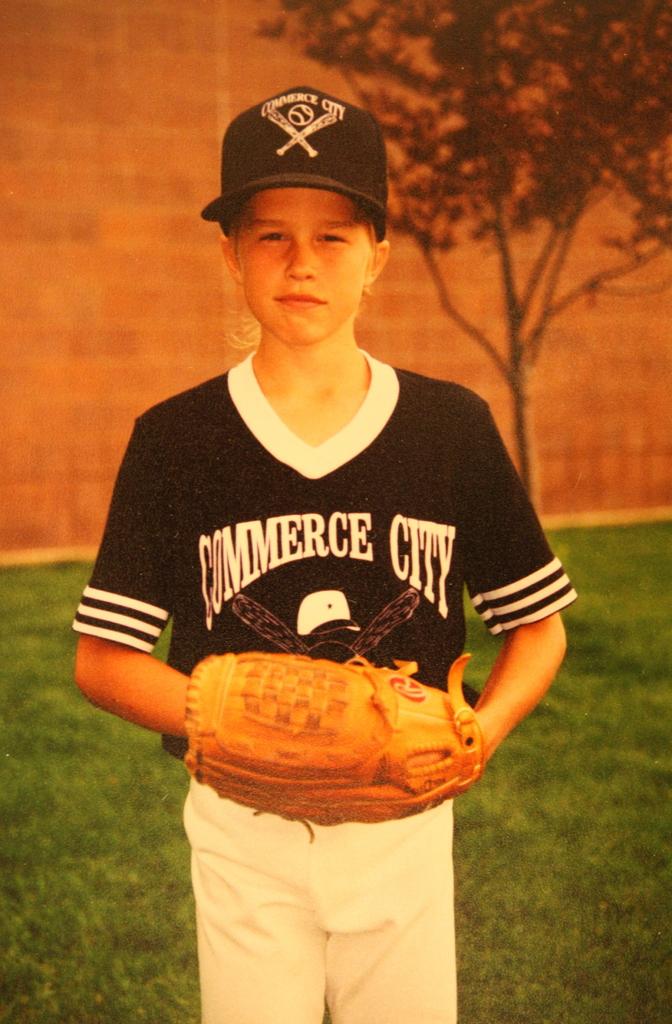What city does the boy play for?
Your response must be concise. Commerce city. 